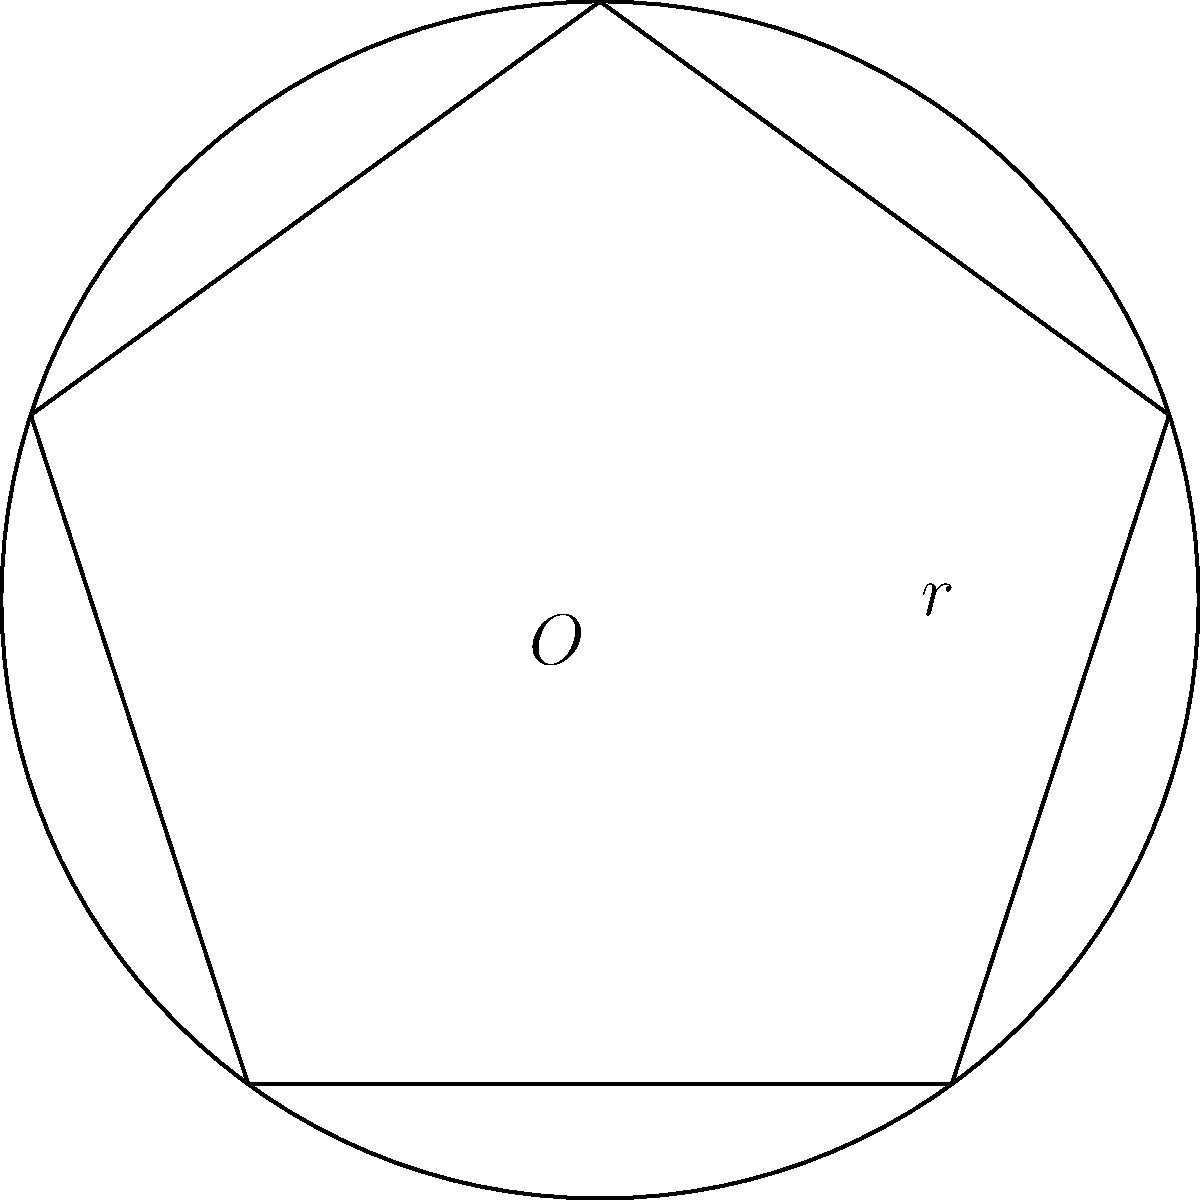In the circle above, a pentagram is inscribed with its points touching the circle's circumference. If the radius of the circle is 6 cm, calculate the area of the pentagram. Round your answer to the nearest square centimeter. Let's approach this step-by-step:

1) First, we need to find the area of the regular pentagon formed by connecting the points of the star.

2) The area of a regular pentagon is given by:
   $$A_{pentagon} = \frac{1}{4}\sqrt{25+10\sqrt{5}}s^2$$
   where $s$ is the side length of the pentagon.

3) To find $s$, we can use the formula:
   $$s = 2r\sin(\frac{\pi}{5})$$
   where $r$ is the radius of the circle.

4) Substituting $r = 6$ cm:
   $$s = 2(6)\sin(\frac{\pi}{5}) \approx 7.0534 \text{ cm}$$

5) Now we can calculate the area of the pentagon:
   $$A_{pentagon} = \frac{1}{4}\sqrt{25+10\sqrt{5}}(7.0534)^2 \approx 84.3015 \text{ cm}^2$$

6) The pentagram is formed by subtracting 5 small triangles from this pentagon.

7) Each small triangle has a base of $s$ and a height of:
   $$h = r - r\cos(\frac{2\pi}{5}) = 6 - 6\cos(\frac{2\pi}{5}) \approx 2.3511 \text{ cm}$$

8) The area of each small triangle is:
   $$A_{triangle} = \frac{1}{2}(7.0534)(2.3511) \approx 8.2867 \text{ cm}^2$$

9) The total area of the 5 small triangles is:
   $$5A_{triangle} \approx 41.4335 \text{ cm}^2$$

10) Therefore, the area of the pentagram is:
    $$A_{pentagram} = A_{pentagon} - 5A_{triangle} \approx 84.3015 - 41.4335 = 42.868 \text{ cm}^2$$

11) Rounding to the nearest square centimeter, we get 43 cm².
Answer: 43 cm² 